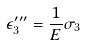Convert formula to latex. <formula><loc_0><loc_0><loc_500><loc_500>\epsilon _ { 3 } ^ { \prime \prime \prime } = \frac { 1 } { E } \sigma _ { 3 }</formula> 